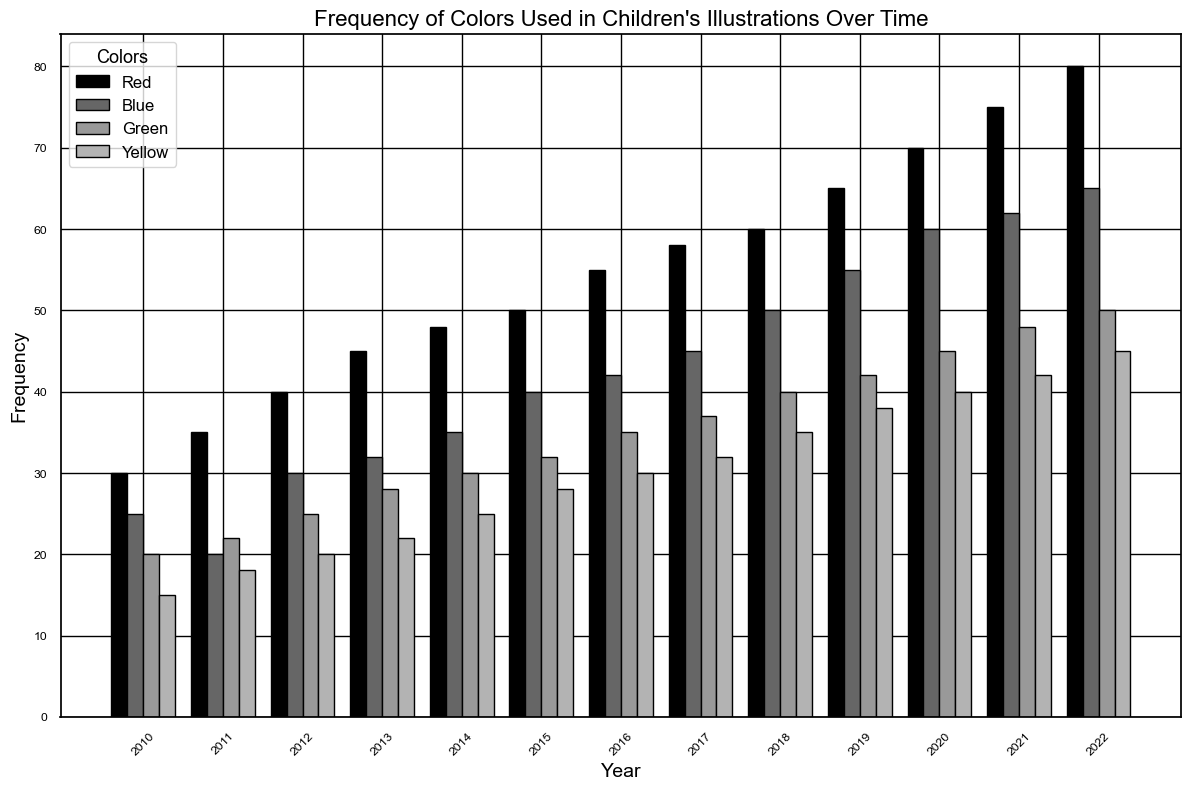What is the frequency of Red used in the year 2015? The bar for Red in 2015 reaches up to a value of 50 on the y-axis, indicating the frequency.
Answer: 50 Which year had the highest frequency of Blue? By looking at the highest point of the Blue bars, 2022 has the highest value.
Answer: 2022 How did the frequency of Green change from 2010 to 2022? By observing the Green bars from 2010 to 2022, the frequency increased from 20 to 50.
Answer: Increased In which year was Yellow used more than Blue? By comparing the bars for Yellow and Blue year by year, you can see that there is no such year; Blue is always higher.
Answer: None Was the Red color used more frequently than Green in 2018? In 2018, the Red bar reaches 60 while the Green bar reaches 40. Therefore, Red is used more frequently.
Answer: Yes Arrange the colors in descending order of their frequency in 2020. For 2020, the frequencies are: Red (70), Blue (60), Green (45), Yellow (40).
Answer: Red, Blue, Green, Yellow What is the average frequency of Yellow between 2010 and 2022? Summing the frequencies of Yellow from 2010 to 2022: 15 + 18 + 20 + 22 + 25 + 28 + 30 + 32 + 35 + 38 + 40 + 42 + 45 = 390. Divide by the number of years (13). 390 / 13 = 30.
Answer: 30 Did the frequency of Blue always increase over the years? By examining the Blue bars, the frequency always increases without any decrease.
Answer: Yes Which color had the lowest frequency in 2011, and what was it? In 2011, the Yellow bar is the shortest, with a frequency of 18.
Answer: Yellow, 18 Calculate the total frequency of Green from 2010 to 2022. Sum the values of Green from 2010 to 2022: 20 + 22 + 25 + 28 + 30 + 32 + 35 + 37 + 40 + 42 + 45 + 48 + 50 = 454.
Answer: 454 